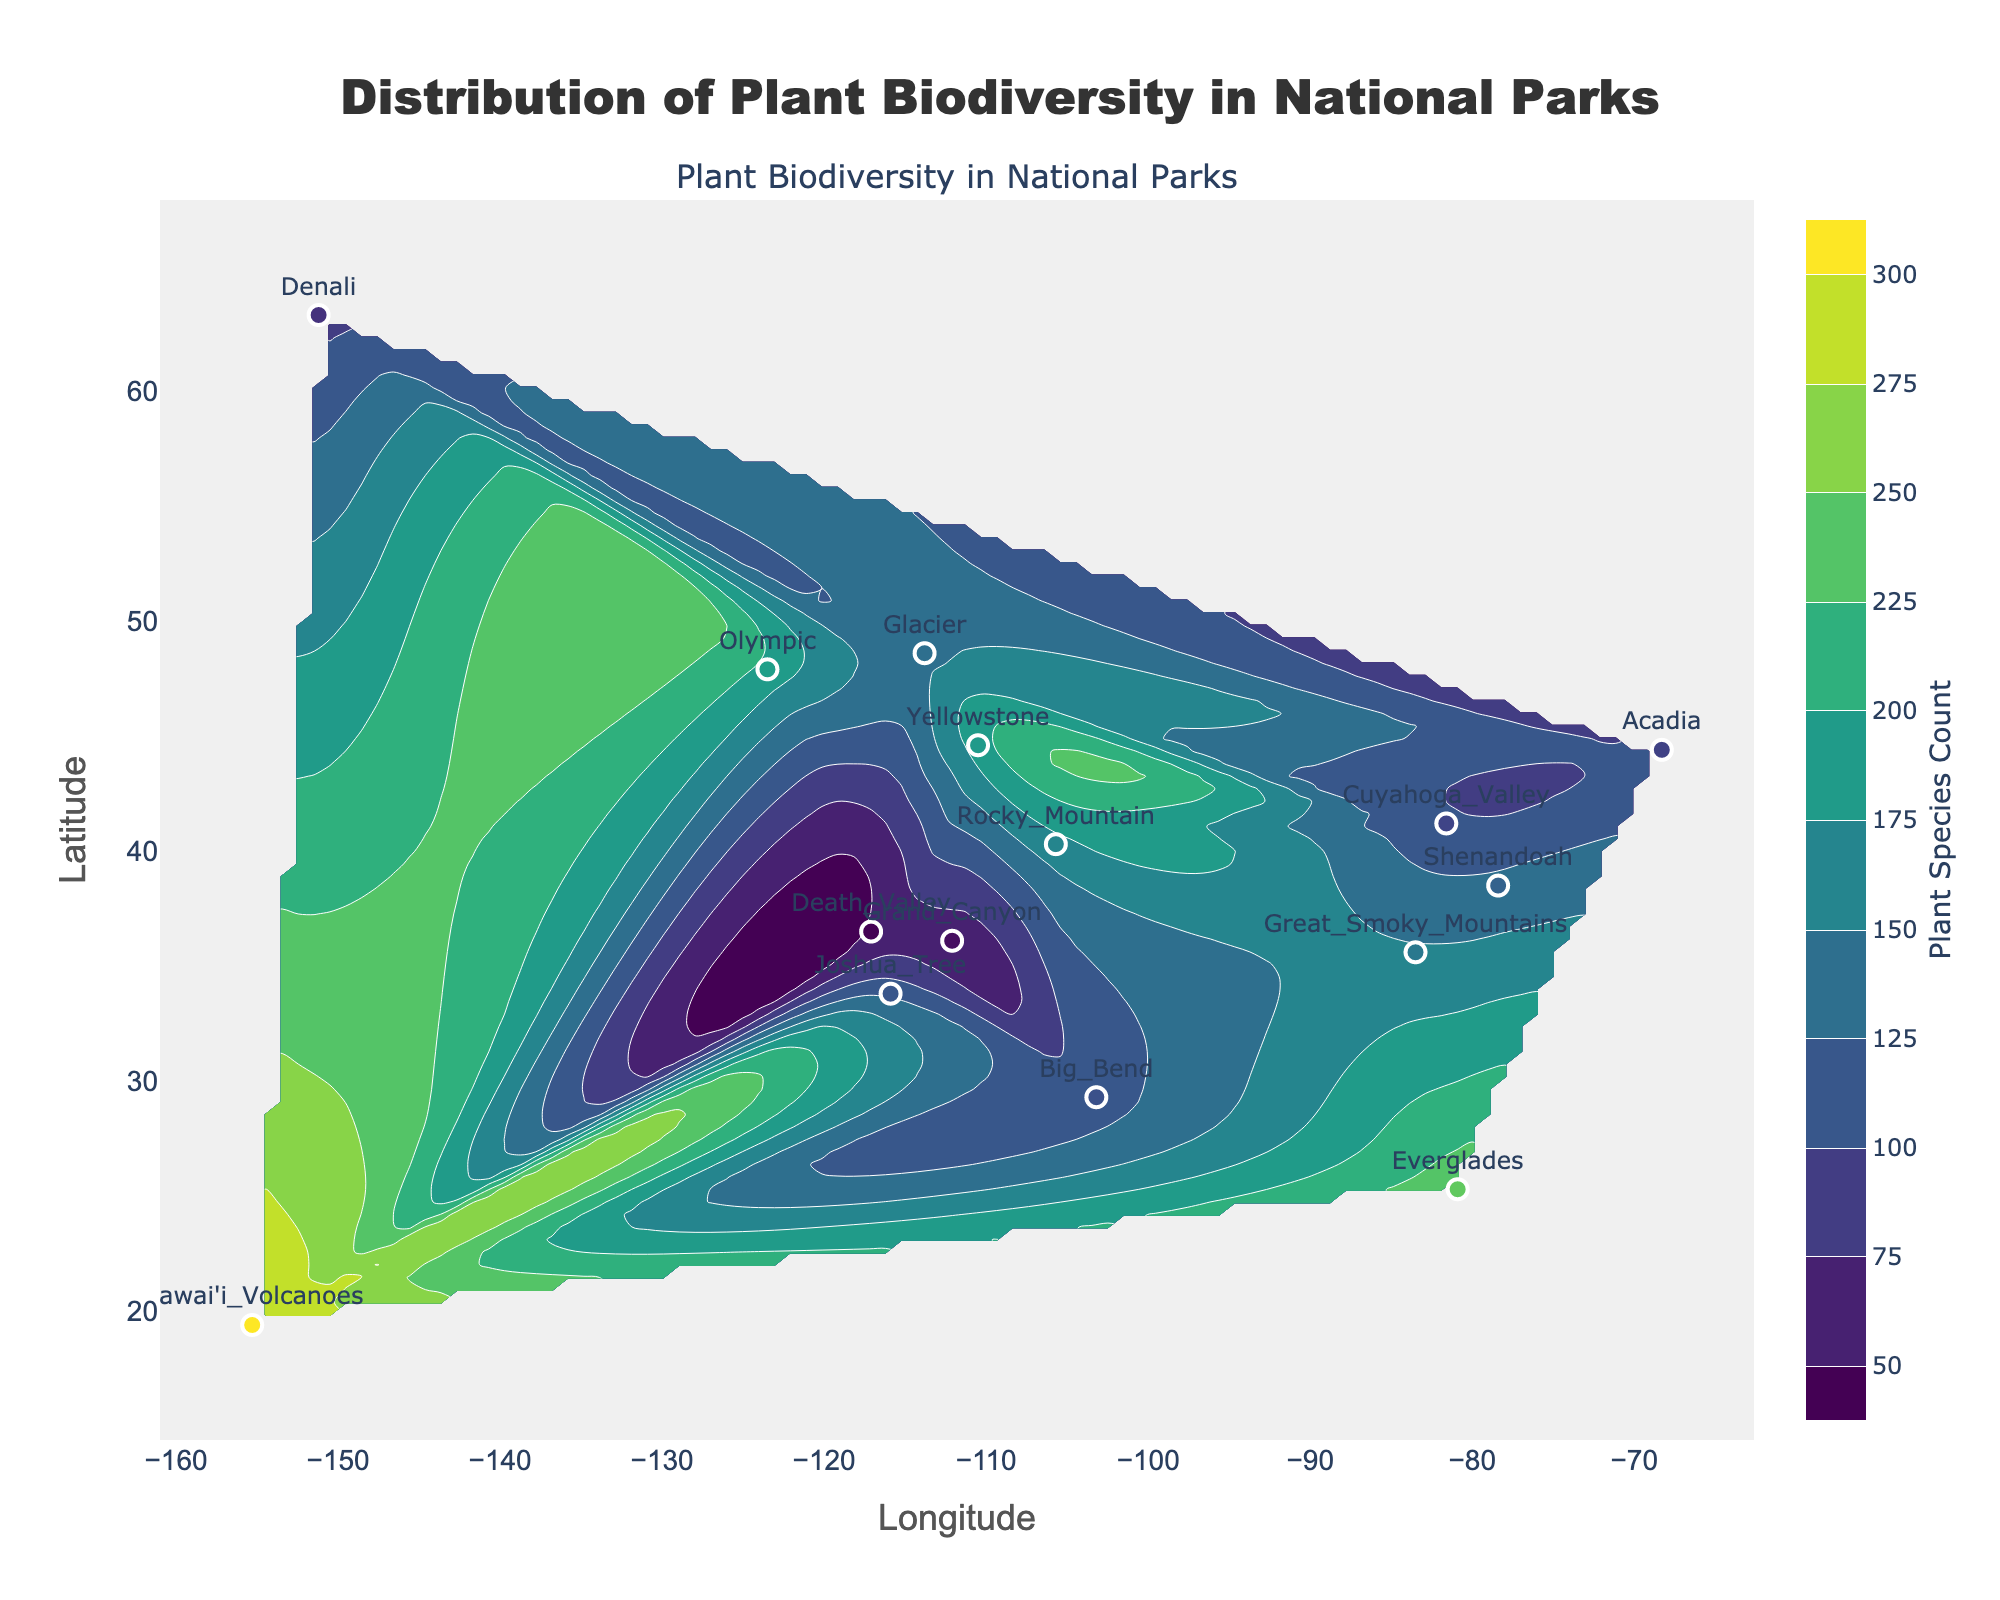What is the title of the plot? The title is usually displayed at the top of the plot area. In this plot, it is located centrally at the top.
Answer: Distribution of Plant Biodiversity in National Parks How many national parks are represented on the plot? By counting the labeled points on the scatter plot overlaying the contour plot, you can see each national park name.
Answer: 15 Which national park has the highest plant species count? The plant species counts are represented by the color intensity on the scatter plot markers, with the values also provided next to each park's name. The park with the highest numeric value is Hawai'i Volcanoes.
Answer: Hawai'i Volcanoes What are the longitude and latitude ranges shown on the plot? The axis titles and tick marks provide the ranges for longitude and latitude. Longitude ranges from roughly -160 to -65, and latitude ranges from roughly 15 to 70.
Answer: Longitude: -160 to -65, Latitude: 15 to 70 Which climate zone has the lowest plant species count and what is the park associated with it? Examining the scatter plot, the park with the lowest value is Death Valley, which is in the Desert climate zone.
Answer: Death Valley, Desert What is the average plant species count of temperate climate national parks? Temperate climate national parks include Yellowstone, Great Smoky Mountains, Shenandoah, Acadia, and Cuyahoga Valley. Add their species counts and divide by the number of parks: (187 + 153 + 131 + 103 + 105) / 5 = 679 / 5.
Answer: 135.8 How does the plant biodiversity distribution in Tropical climate zones compare to that in Desert climate zones? The total species count for Tropical parks (Everglades and Hawai'i Volcanoes) is 240 + 301 = 541. The total for Desert parks (Joshua Tree, Death Valley, Grand Canyon, and Big Bend) is 120 + 54 + 63 + 116 = 353. The Tropical zone has higher biodiversity.
Answer: Tropical > Desert Which national park located west of -110 longitude has the highest plant species count, and what is that count? Looking at national parks west of -110 longitude and comparing their species counts: Yellowstone, Denali, Olympic, Glacier, and Hawai'i Volcanoes are the options. Hawai'i Volcanoes has the highest count of 301.
Answer: Hawai'i Volcanoes, 301 Is the Grand Canyon's plant species count higher or lower than Joshua Tree's? Comparing the numeric values provided next to their names, Grand Canyon has 63 species and Joshua Tree has 120 species.
Answer: Lower 